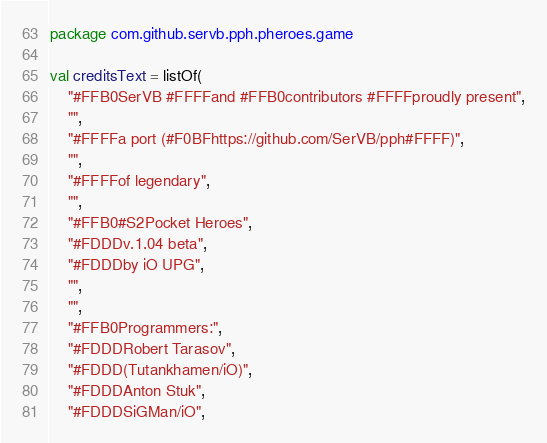Convert code to text. <code><loc_0><loc_0><loc_500><loc_500><_Kotlin_>package com.github.servb.pph.pheroes.game

val creditsText = listOf(
    "#FFB0SerVB #FFFFand #FFB0contributors #FFFFproudly present",
    "",
    "#FFFFa port (#F0BFhttps://github.com/SerVB/pph#FFFF)",
    "",
    "#FFFFof legendary",
    "",
    "#FFB0#S2Pocket Heroes",
    "#FDDDv.1.04 beta",
    "#FDDDby iO UPG",
    "",
    "",
    "#FFB0Programmers:",
    "#FDDDRobert Tarasov",
    "#FDDD(Tutankhamen/iO)",
    "#FDDDAnton Stuk",
    "#FDDDSiGMan/iO",</code> 